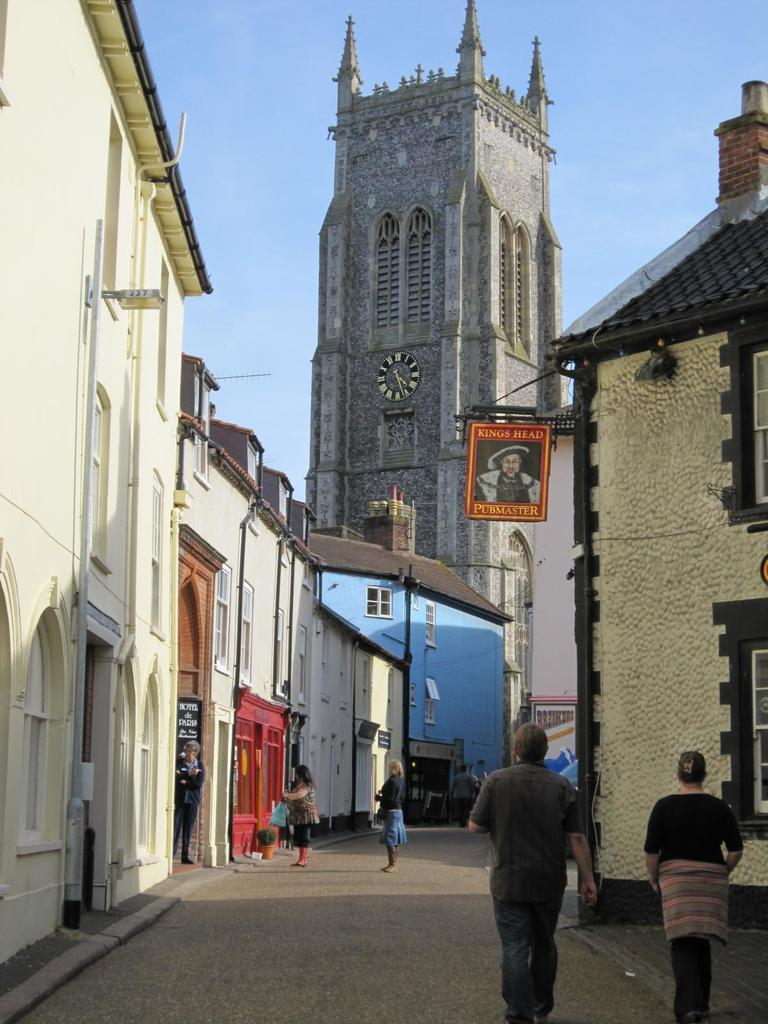What is the primary subject of the image? The primary subject of the image is the many buildings. What is located at the bottom of the image? There is a road at the bottom of the image. How many people can be seen in the front of the image? There are five persons in the front of the image. What can be seen at the top of the image? The sky is visible at the top of the image. What type of beast can be seen roaming the streets in the image? There is no beast present in the image; it features buildings, a road, people, and the sky. What kind of sponge is being used to clean the windows of the buildings in the image? There is no sponge or window cleaning activity depicted in the image. 